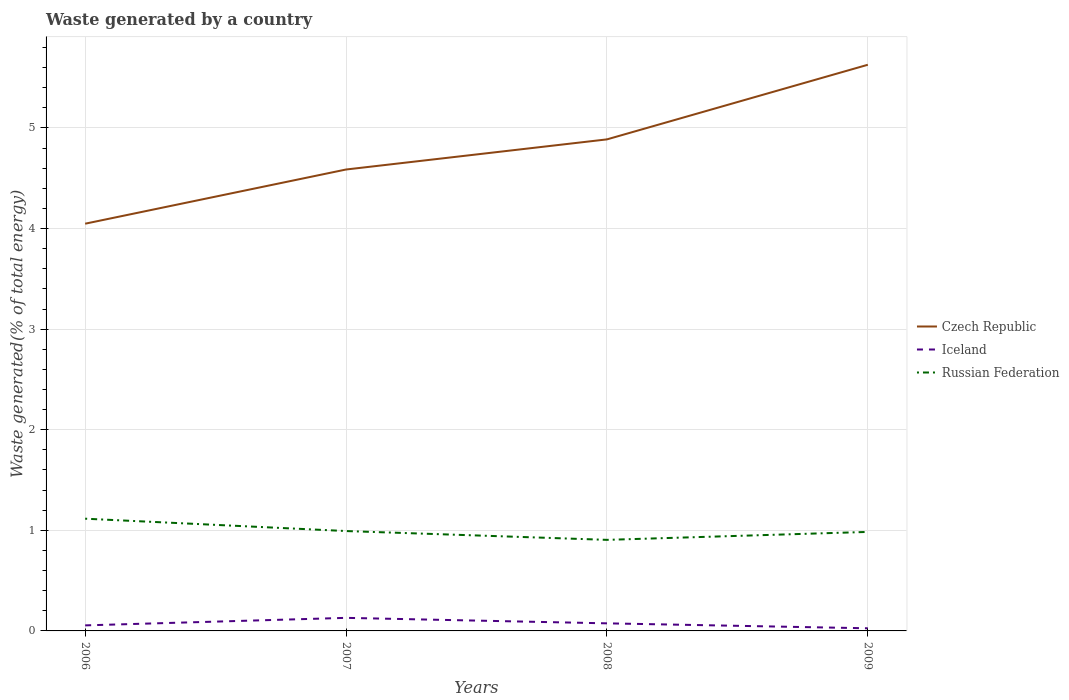Does the line corresponding to Iceland intersect with the line corresponding to Czech Republic?
Provide a succinct answer. No. Is the number of lines equal to the number of legend labels?
Make the answer very short. Yes. Across all years, what is the maximum total waste generated in Iceland?
Your answer should be very brief. 0.03. What is the total total waste generated in Iceland in the graph?
Give a very brief answer. 0.03. What is the difference between the highest and the second highest total waste generated in Iceland?
Make the answer very short. 0.1. What is the difference between the highest and the lowest total waste generated in Russian Federation?
Your response must be concise. 1. How many lines are there?
Keep it short and to the point. 3. How many years are there in the graph?
Give a very brief answer. 4. What is the difference between two consecutive major ticks on the Y-axis?
Provide a succinct answer. 1. Are the values on the major ticks of Y-axis written in scientific E-notation?
Offer a very short reply. No. What is the title of the graph?
Provide a succinct answer. Waste generated by a country. Does "Germany" appear as one of the legend labels in the graph?
Provide a short and direct response. No. What is the label or title of the X-axis?
Make the answer very short. Years. What is the label or title of the Y-axis?
Ensure brevity in your answer.  Waste generated(% of total energy). What is the Waste generated(% of total energy) of Czech Republic in 2006?
Make the answer very short. 4.05. What is the Waste generated(% of total energy) of Iceland in 2006?
Your answer should be compact. 0.06. What is the Waste generated(% of total energy) of Russian Federation in 2006?
Provide a succinct answer. 1.12. What is the Waste generated(% of total energy) in Czech Republic in 2007?
Offer a terse response. 4.59. What is the Waste generated(% of total energy) in Iceland in 2007?
Provide a short and direct response. 0.13. What is the Waste generated(% of total energy) in Russian Federation in 2007?
Offer a very short reply. 0.99. What is the Waste generated(% of total energy) in Czech Republic in 2008?
Your answer should be very brief. 4.89. What is the Waste generated(% of total energy) of Iceland in 2008?
Give a very brief answer. 0.08. What is the Waste generated(% of total energy) in Russian Federation in 2008?
Your response must be concise. 0.91. What is the Waste generated(% of total energy) in Czech Republic in 2009?
Offer a terse response. 5.63. What is the Waste generated(% of total energy) of Iceland in 2009?
Provide a succinct answer. 0.03. What is the Waste generated(% of total energy) of Russian Federation in 2009?
Your answer should be compact. 0.98. Across all years, what is the maximum Waste generated(% of total energy) in Czech Republic?
Provide a short and direct response. 5.63. Across all years, what is the maximum Waste generated(% of total energy) in Iceland?
Give a very brief answer. 0.13. Across all years, what is the maximum Waste generated(% of total energy) in Russian Federation?
Keep it short and to the point. 1.12. Across all years, what is the minimum Waste generated(% of total energy) of Czech Republic?
Offer a terse response. 4.05. Across all years, what is the minimum Waste generated(% of total energy) in Iceland?
Ensure brevity in your answer.  0.03. Across all years, what is the minimum Waste generated(% of total energy) in Russian Federation?
Your answer should be very brief. 0.91. What is the total Waste generated(% of total energy) of Czech Republic in the graph?
Ensure brevity in your answer.  19.15. What is the total Waste generated(% of total energy) of Iceland in the graph?
Keep it short and to the point. 0.29. What is the total Waste generated(% of total energy) in Russian Federation in the graph?
Your answer should be compact. 4. What is the difference between the Waste generated(% of total energy) of Czech Republic in 2006 and that in 2007?
Keep it short and to the point. -0.54. What is the difference between the Waste generated(% of total energy) in Iceland in 2006 and that in 2007?
Ensure brevity in your answer.  -0.07. What is the difference between the Waste generated(% of total energy) of Russian Federation in 2006 and that in 2007?
Make the answer very short. 0.12. What is the difference between the Waste generated(% of total energy) of Czech Republic in 2006 and that in 2008?
Your answer should be very brief. -0.84. What is the difference between the Waste generated(% of total energy) in Iceland in 2006 and that in 2008?
Offer a very short reply. -0.02. What is the difference between the Waste generated(% of total energy) in Russian Federation in 2006 and that in 2008?
Provide a short and direct response. 0.21. What is the difference between the Waste generated(% of total energy) in Czech Republic in 2006 and that in 2009?
Offer a terse response. -1.58. What is the difference between the Waste generated(% of total energy) in Iceland in 2006 and that in 2009?
Offer a terse response. 0.03. What is the difference between the Waste generated(% of total energy) of Russian Federation in 2006 and that in 2009?
Make the answer very short. 0.13. What is the difference between the Waste generated(% of total energy) of Czech Republic in 2007 and that in 2008?
Give a very brief answer. -0.3. What is the difference between the Waste generated(% of total energy) of Iceland in 2007 and that in 2008?
Your answer should be very brief. 0.05. What is the difference between the Waste generated(% of total energy) of Russian Federation in 2007 and that in 2008?
Offer a terse response. 0.09. What is the difference between the Waste generated(% of total energy) in Czech Republic in 2007 and that in 2009?
Your answer should be compact. -1.04. What is the difference between the Waste generated(% of total energy) in Iceland in 2007 and that in 2009?
Offer a terse response. 0.1. What is the difference between the Waste generated(% of total energy) of Russian Federation in 2007 and that in 2009?
Provide a short and direct response. 0.01. What is the difference between the Waste generated(% of total energy) of Czech Republic in 2008 and that in 2009?
Offer a very short reply. -0.74. What is the difference between the Waste generated(% of total energy) in Iceland in 2008 and that in 2009?
Your answer should be compact. 0.05. What is the difference between the Waste generated(% of total energy) in Russian Federation in 2008 and that in 2009?
Provide a short and direct response. -0.08. What is the difference between the Waste generated(% of total energy) in Czech Republic in 2006 and the Waste generated(% of total energy) in Iceland in 2007?
Your response must be concise. 3.92. What is the difference between the Waste generated(% of total energy) in Czech Republic in 2006 and the Waste generated(% of total energy) in Russian Federation in 2007?
Your answer should be compact. 3.06. What is the difference between the Waste generated(% of total energy) of Iceland in 2006 and the Waste generated(% of total energy) of Russian Federation in 2007?
Give a very brief answer. -0.94. What is the difference between the Waste generated(% of total energy) in Czech Republic in 2006 and the Waste generated(% of total energy) in Iceland in 2008?
Your answer should be very brief. 3.97. What is the difference between the Waste generated(% of total energy) in Czech Republic in 2006 and the Waste generated(% of total energy) in Russian Federation in 2008?
Your response must be concise. 3.14. What is the difference between the Waste generated(% of total energy) in Iceland in 2006 and the Waste generated(% of total energy) in Russian Federation in 2008?
Your answer should be compact. -0.85. What is the difference between the Waste generated(% of total energy) in Czech Republic in 2006 and the Waste generated(% of total energy) in Iceland in 2009?
Keep it short and to the point. 4.02. What is the difference between the Waste generated(% of total energy) in Czech Republic in 2006 and the Waste generated(% of total energy) in Russian Federation in 2009?
Offer a very short reply. 3.06. What is the difference between the Waste generated(% of total energy) of Iceland in 2006 and the Waste generated(% of total energy) of Russian Federation in 2009?
Keep it short and to the point. -0.93. What is the difference between the Waste generated(% of total energy) of Czech Republic in 2007 and the Waste generated(% of total energy) of Iceland in 2008?
Provide a succinct answer. 4.51. What is the difference between the Waste generated(% of total energy) of Czech Republic in 2007 and the Waste generated(% of total energy) of Russian Federation in 2008?
Offer a very short reply. 3.68. What is the difference between the Waste generated(% of total energy) of Iceland in 2007 and the Waste generated(% of total energy) of Russian Federation in 2008?
Give a very brief answer. -0.78. What is the difference between the Waste generated(% of total energy) of Czech Republic in 2007 and the Waste generated(% of total energy) of Iceland in 2009?
Provide a short and direct response. 4.56. What is the difference between the Waste generated(% of total energy) in Czech Republic in 2007 and the Waste generated(% of total energy) in Russian Federation in 2009?
Your answer should be compact. 3.6. What is the difference between the Waste generated(% of total energy) in Iceland in 2007 and the Waste generated(% of total energy) in Russian Federation in 2009?
Your response must be concise. -0.85. What is the difference between the Waste generated(% of total energy) of Czech Republic in 2008 and the Waste generated(% of total energy) of Iceland in 2009?
Your answer should be very brief. 4.86. What is the difference between the Waste generated(% of total energy) in Czech Republic in 2008 and the Waste generated(% of total energy) in Russian Federation in 2009?
Keep it short and to the point. 3.9. What is the difference between the Waste generated(% of total energy) in Iceland in 2008 and the Waste generated(% of total energy) in Russian Federation in 2009?
Offer a terse response. -0.91. What is the average Waste generated(% of total energy) in Czech Republic per year?
Give a very brief answer. 4.79. What is the average Waste generated(% of total energy) in Iceland per year?
Make the answer very short. 0.07. What is the average Waste generated(% of total energy) in Russian Federation per year?
Your answer should be compact. 1. In the year 2006, what is the difference between the Waste generated(% of total energy) in Czech Republic and Waste generated(% of total energy) in Iceland?
Make the answer very short. 3.99. In the year 2006, what is the difference between the Waste generated(% of total energy) in Czech Republic and Waste generated(% of total energy) in Russian Federation?
Provide a succinct answer. 2.93. In the year 2006, what is the difference between the Waste generated(% of total energy) of Iceland and Waste generated(% of total energy) of Russian Federation?
Ensure brevity in your answer.  -1.06. In the year 2007, what is the difference between the Waste generated(% of total energy) of Czech Republic and Waste generated(% of total energy) of Iceland?
Provide a short and direct response. 4.46. In the year 2007, what is the difference between the Waste generated(% of total energy) in Czech Republic and Waste generated(% of total energy) in Russian Federation?
Provide a succinct answer. 3.59. In the year 2007, what is the difference between the Waste generated(% of total energy) of Iceland and Waste generated(% of total energy) of Russian Federation?
Make the answer very short. -0.86. In the year 2008, what is the difference between the Waste generated(% of total energy) of Czech Republic and Waste generated(% of total energy) of Iceland?
Offer a very short reply. 4.81. In the year 2008, what is the difference between the Waste generated(% of total energy) of Czech Republic and Waste generated(% of total energy) of Russian Federation?
Offer a very short reply. 3.98. In the year 2008, what is the difference between the Waste generated(% of total energy) in Iceland and Waste generated(% of total energy) in Russian Federation?
Your answer should be very brief. -0.83. In the year 2009, what is the difference between the Waste generated(% of total energy) of Czech Republic and Waste generated(% of total energy) of Iceland?
Your response must be concise. 5.6. In the year 2009, what is the difference between the Waste generated(% of total energy) of Czech Republic and Waste generated(% of total energy) of Russian Federation?
Offer a terse response. 4.64. In the year 2009, what is the difference between the Waste generated(% of total energy) in Iceland and Waste generated(% of total energy) in Russian Federation?
Offer a very short reply. -0.96. What is the ratio of the Waste generated(% of total energy) in Czech Republic in 2006 to that in 2007?
Make the answer very short. 0.88. What is the ratio of the Waste generated(% of total energy) of Iceland in 2006 to that in 2007?
Your response must be concise. 0.42. What is the ratio of the Waste generated(% of total energy) of Russian Federation in 2006 to that in 2007?
Your answer should be very brief. 1.12. What is the ratio of the Waste generated(% of total energy) in Czech Republic in 2006 to that in 2008?
Provide a short and direct response. 0.83. What is the ratio of the Waste generated(% of total energy) in Iceland in 2006 to that in 2008?
Offer a very short reply. 0.73. What is the ratio of the Waste generated(% of total energy) of Russian Federation in 2006 to that in 2008?
Offer a terse response. 1.23. What is the ratio of the Waste generated(% of total energy) in Czech Republic in 2006 to that in 2009?
Keep it short and to the point. 0.72. What is the ratio of the Waste generated(% of total energy) in Iceland in 2006 to that in 2009?
Your answer should be compact. 2.11. What is the ratio of the Waste generated(% of total energy) of Russian Federation in 2006 to that in 2009?
Your answer should be very brief. 1.13. What is the ratio of the Waste generated(% of total energy) in Czech Republic in 2007 to that in 2008?
Your answer should be very brief. 0.94. What is the ratio of the Waste generated(% of total energy) in Iceland in 2007 to that in 2008?
Ensure brevity in your answer.  1.72. What is the ratio of the Waste generated(% of total energy) in Russian Federation in 2007 to that in 2008?
Provide a short and direct response. 1.1. What is the ratio of the Waste generated(% of total energy) in Czech Republic in 2007 to that in 2009?
Give a very brief answer. 0.81. What is the ratio of the Waste generated(% of total energy) of Iceland in 2007 to that in 2009?
Offer a terse response. 4.96. What is the ratio of the Waste generated(% of total energy) of Russian Federation in 2007 to that in 2009?
Offer a terse response. 1.01. What is the ratio of the Waste generated(% of total energy) in Czech Republic in 2008 to that in 2009?
Your answer should be very brief. 0.87. What is the ratio of the Waste generated(% of total energy) of Iceland in 2008 to that in 2009?
Your response must be concise. 2.88. What is the ratio of the Waste generated(% of total energy) in Russian Federation in 2008 to that in 2009?
Your response must be concise. 0.92. What is the difference between the highest and the second highest Waste generated(% of total energy) of Czech Republic?
Offer a very short reply. 0.74. What is the difference between the highest and the second highest Waste generated(% of total energy) in Iceland?
Offer a terse response. 0.05. What is the difference between the highest and the second highest Waste generated(% of total energy) of Russian Federation?
Your answer should be compact. 0.12. What is the difference between the highest and the lowest Waste generated(% of total energy) in Czech Republic?
Offer a terse response. 1.58. What is the difference between the highest and the lowest Waste generated(% of total energy) in Iceland?
Ensure brevity in your answer.  0.1. What is the difference between the highest and the lowest Waste generated(% of total energy) in Russian Federation?
Give a very brief answer. 0.21. 